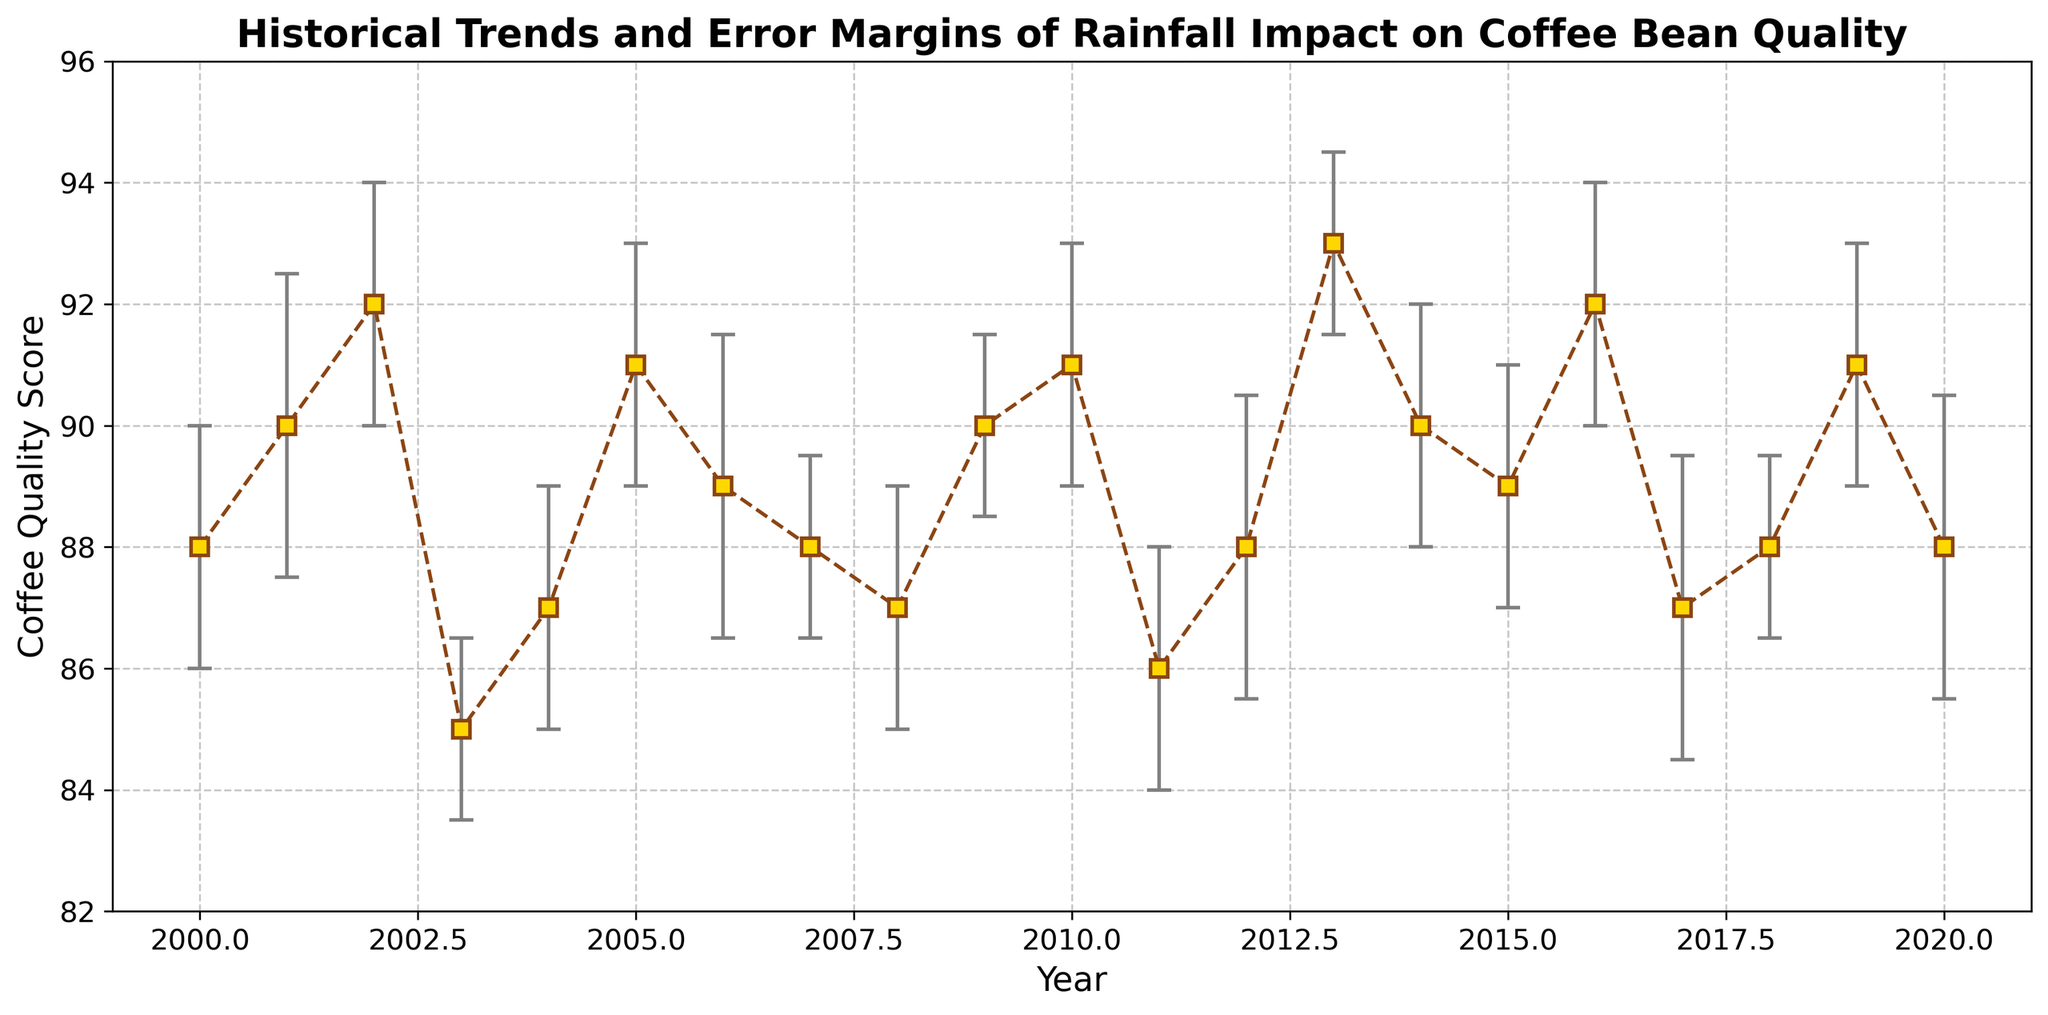What is the general trend in Coffee Quality Score from 2000 to 2020? Observing the graph, we can see that there is a general upward trend in the Coffee Quality Score from around 88 in 2000 to approximately 91 in 2020, with some fluctuations in between.
Answer: Upward trend In which year was the Coffee Quality Score the highest, and what was the score? By examining the peaks in the graph, the highest Coffee Quality Score occurred in 2013, reaching a score of 93.
Answer: 2013, 93 Which year had the lowest Coffee Quality Score and what was the score? From the graph, we can identify the lowest Coffee Quality Score to be in 2003 with a score of 85.
Answer: 2003, 85 How do the error margins in 2000 compare to those in 2013? In the graph, the error margin in 2000 is represented as 2, while in 2013, the error margin is slightly lower at 1.5. This means the error margin decreased from 2000 to 2013.
Answer: 2000: 2, 2013: 1.5 What significant changes in the Coffee Quality Score occurred between 2003 and 2004? By looking at the graph, we see that the Coffee Quality Score increased significantly from 85 in 2003 to 87 in 2004.
Answer: Increase by 2 points In which year did the Coffee Quality Score experience a significant drop, and by how many points? Noticing the steep declines, we see a significant drop from 92 in 2002 to 85 in 2003, representing a 7-point decrease.
Answer: 2003, drop of 7 points What is the range of Coffee Quality Scores observed in the figure? By identifying the highest and lowest values in the graph, the range is from 85 (lowest in 2003) to 93 (highest in 2013), which gives a range of 8 points.
Answer: 8 points What are the average Coffee Quality Scores for the years with Avg Rainfall between 1200 and 1300 mm? Narrow down the years with Avg Rainfall between 1200 and 1300 mm and calculate their average Coffee Quality Scores: (88 (2000) + 90 (2001) + 92 (2002) + 88 (2007) + 87 (2008) + 90 (2009) + 91 (2010) + 88 (2018) + 88 (2020)) / 9 = 87 .
Answer: 89.33 Which year has the highest Coffee Quality Score with the smallest error margin, and what are the values? Identify the peak Coffee Quality Score with the smallest error margin. In 2013, the score was 93 with an error margin of 1.5.
Answer: 2013, 93, 1.5 What was the change in Coffee Quality Score from 2003 to 2013? Comparing the scores between these years, there was an increase from 85 in 2003 to 93 in 2013, resulting in a change of 8 points.
Answer: Increase by 8 points 